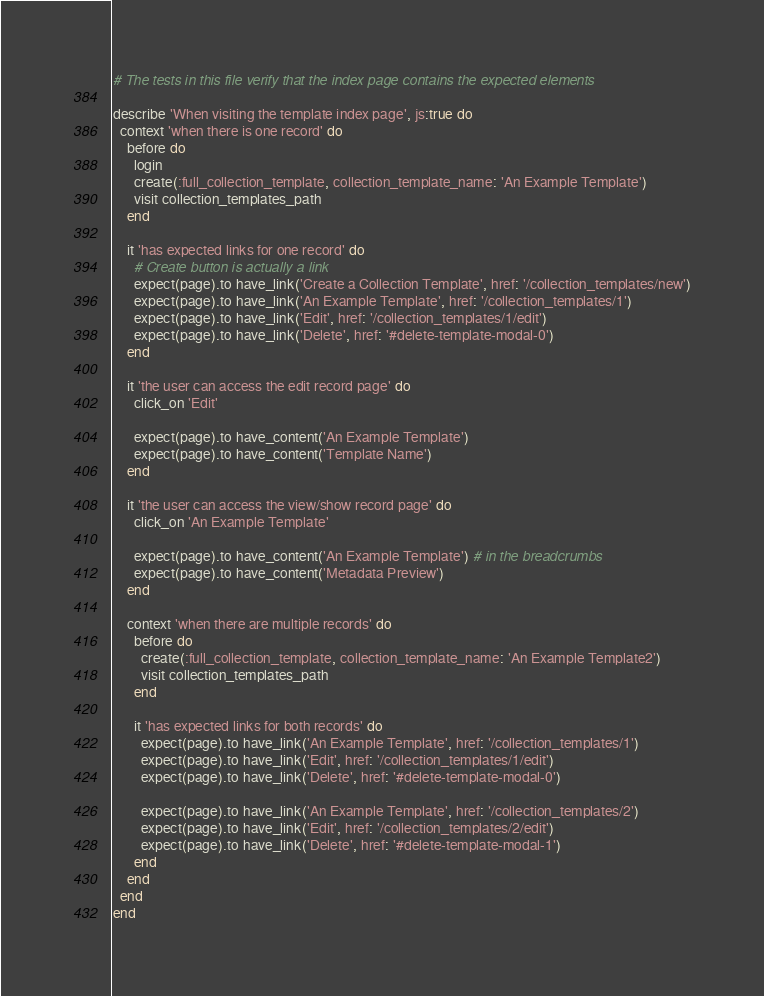<code> <loc_0><loc_0><loc_500><loc_500><_Ruby_># The tests in this file verify that the index page contains the expected elements

describe 'When visiting the template index page', js:true do
  context 'when there is one record' do
    before do
      login
      create(:full_collection_template, collection_template_name: 'An Example Template')
      visit collection_templates_path
    end

    it 'has expected links for one record' do
      # Create button is actually a link
      expect(page).to have_link('Create a Collection Template', href: '/collection_templates/new')
      expect(page).to have_link('An Example Template', href: '/collection_templates/1')
      expect(page).to have_link('Edit', href: '/collection_templates/1/edit')
      expect(page).to have_link('Delete', href: '#delete-template-modal-0')
    end

    it 'the user can access the edit record page' do
      click_on 'Edit'

      expect(page).to have_content('An Example Template')
      expect(page).to have_content('Template Name')
    end

    it 'the user can access the view/show record page' do
      click_on 'An Example Template'

      expect(page).to have_content('An Example Template') # in the breadcrumbs
      expect(page).to have_content('Metadata Preview')
    end
    
    context 'when there are multiple records' do
      before do
        create(:full_collection_template, collection_template_name: 'An Example Template2')
        visit collection_templates_path
      end

      it 'has expected links for both records' do
        expect(page).to have_link('An Example Template', href: '/collection_templates/1')
        expect(page).to have_link('Edit', href: '/collection_templates/1/edit')
        expect(page).to have_link('Delete', href: '#delete-template-modal-0')

        expect(page).to have_link('An Example Template', href: '/collection_templates/2')
        expect(page).to have_link('Edit', href: '/collection_templates/2/edit')
        expect(page).to have_link('Delete', href: '#delete-template-modal-1')
      end
    end
  end
end
</code> 